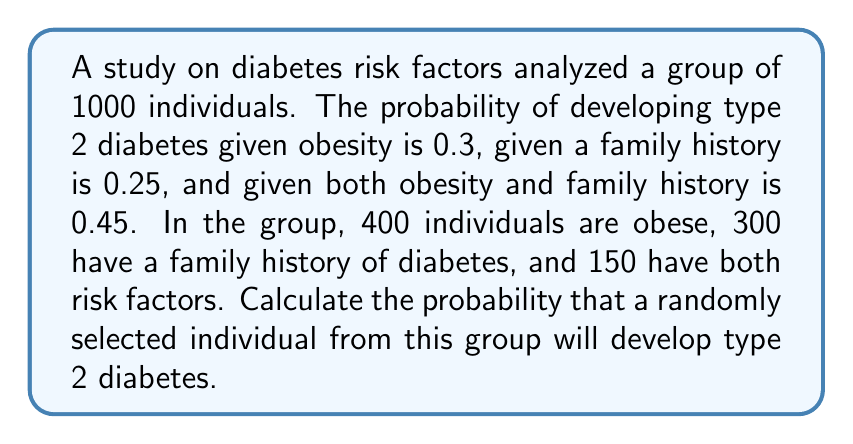Can you answer this question? Let's approach this step-by-step using the given information and the law of total probability.

1) Define events:
   A: Individual develops type 2 diabetes
   O: Individual is obese
   F: Individual has family history of diabetes

2) Given probabilities:
   P(A|O) = 0.3
   P(A|F) = 0.25
   P(A|O∩F) = 0.45

3) Calculate probabilities for each subgroup:
   P(O) = 400/1000 = 0.4
   P(F) = 300/1000 = 0.3
   P(O∩F) = 150/1000 = 0.15

4) Calculate P(O∪F) using the inclusion-exclusion principle:
   P(O∪F) = P(O) + P(F) - P(O∩F) = 0.4 + 0.3 - 0.15 = 0.55

5) Use the law of total probability:
   P(A) = P(A|O∩F)P(O∩F) + P(A|O∩F^c)P(O∩F^c) + P(A|O^c∩F)P(O^c∩F) + P(A|O^c∩F^c)P(O^c∩F^c)

   Where:
   P(O∩F^c) = P(O) - P(O∩F) = 0.4 - 0.15 = 0.25
   P(O^c∩F) = P(F) - P(O∩F) = 0.3 - 0.15 = 0.15
   P(O^c∩F^c) = 1 - P(O∪F) = 1 - 0.55 = 0.45

   P(A|O∩F^c) and P(A|O^c∩F) are not directly given, but we can estimate them using the given probabilities:
   P(A|O∩F^c) ≈ P(A|O) = 0.3
   P(A|O^c∩F) ≈ P(A|F) = 0.25

   Assume P(A|O^c∩F^c) = 0.1 (baseline risk for individuals with no known risk factors)

6) Substituting into the formula:
   P(A) = 0.45 * 0.15 + 0.3 * 0.25 + 0.25 * 0.15 + 0.1 * 0.45
        = 0.0675 + 0.075 + 0.0375 + 0.045
        = 0.225

Therefore, the probability that a randomly selected individual from this group will develop type 2 diabetes is approximately 0.225 or 22.5%.
Answer: 0.225 